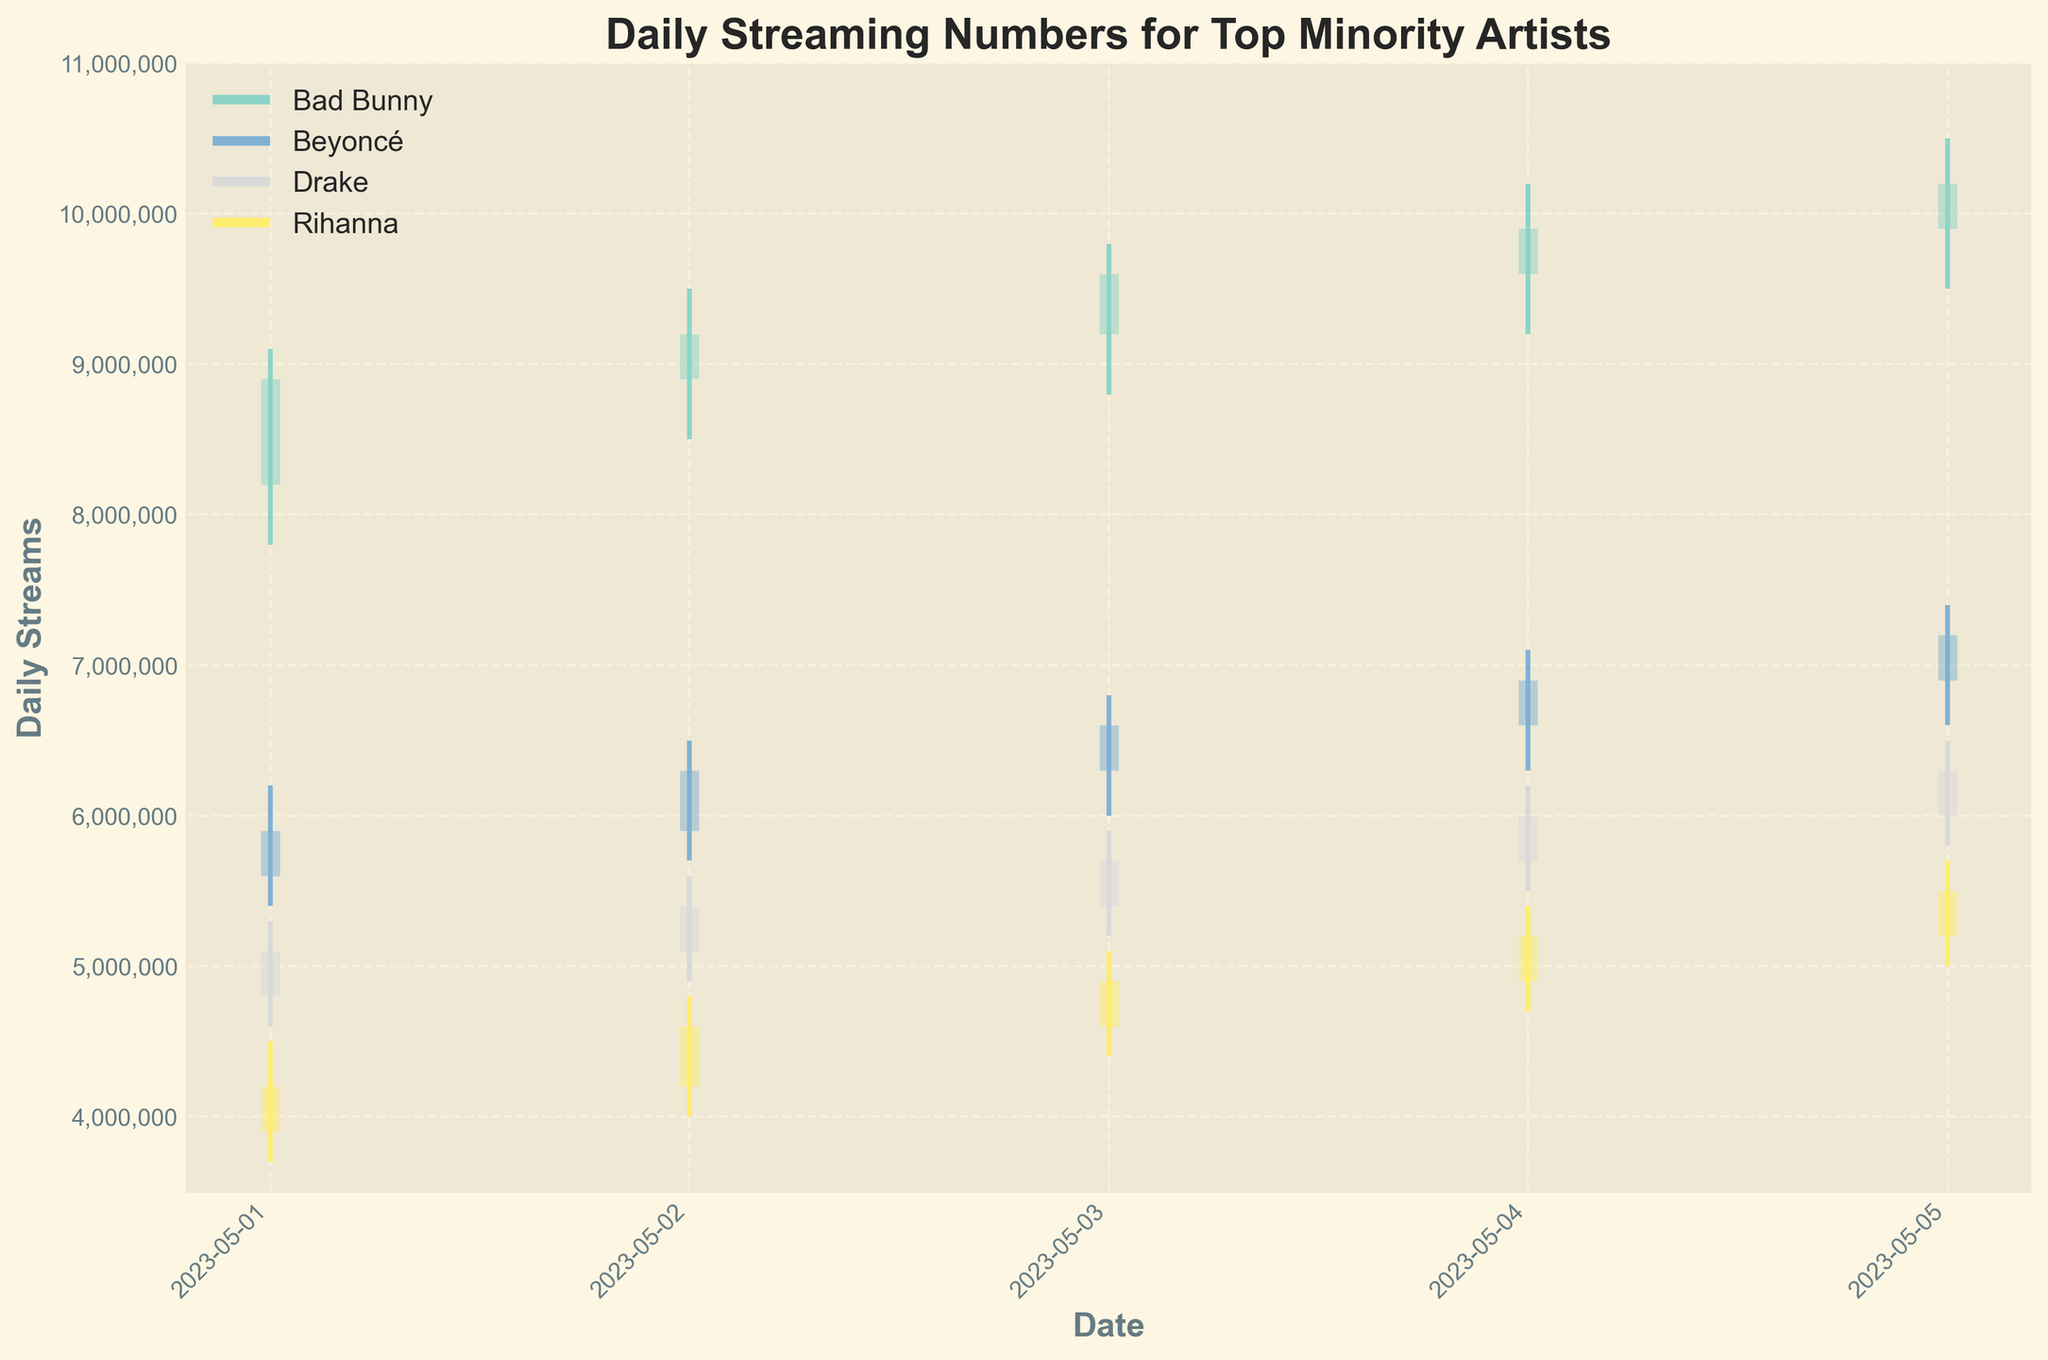What is the title of the figure? Look at the top of the chart where the main heading is displayed. The title will be written in bold and larger font compared to the rest of the text.
Answer: Daily Streaming Numbers for Top Minority Artists What is the Y-axis label? Check the vertical axis on the left side of the figure. The label for this axis should be displayed prominently.
Answer: Daily Streams Which artist had the highest closing streaming number on Spotify on May 5th, 2023? Look at the OHLC data for the different artists on May 5th. Compare the closing values and identify the highest one for Spotify.
Answer: Bad Bunny By how much did Beyoncé's streaming numbers on Apple Music increase from May 1st to May 5th, based on the closing values? Find Beyoncé's closing streaming numbers for May 1st and May 5th. Subtract the May 1st value from the May 5th value to get the increase.
Answer: 1,300,000 On which date did Drake have the lowest opening value on YouTube Music? Inspect the opening values for each date corresponding to Drake. Identify the date with the lowest opening number.
Answer: May 1st, 2023 Which artist had the most consistent streaming numbers on Amazon Music during the given time period? Calculate the range (high value - low value) for each artist on Amazon Music over the given dates. The artist with the smallest range has the most consistent numbers.
Answer: Rihanna How did Bad Bunny's closing value on Spotify change from May 3rd to May 4th? Compare the closing values for Bad Bunny on these two dates. Identify the difference in numbers.
Answer: Increased by 30,000 Which platform shows the highest variability in streaming numbers for Beyoncé? For each platform, calculate the difference between the highest high and the lowest low values for Beyoncé. The platform with the highest difference shows the highest variability.
Answer: Apple Music Compare the highest high values for Drake and Rihanna. Who had the higher peak streaming number during the period? Find the highest high value for both Drake and Rihanna. Compare these peak values to determine who had the higher peak streaming number.
Answer: Drake What trend can you observe for Rihanna's streaming numbers on Amazon Music from May 1st to May 5th? Look at the closing values for Rihanna over the given dates. Assess whether the values are increasing, decreasing, or fluctuating to identify any trend.
Answer: Increasing 